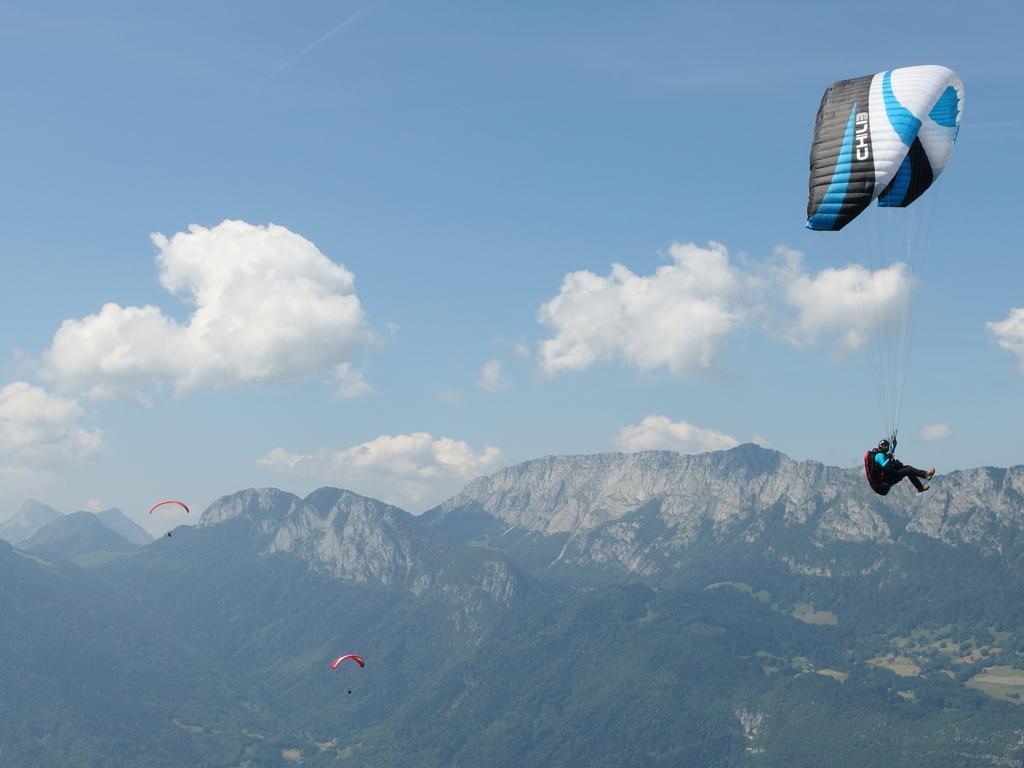How would you summarize this image in a sentence or two? In this image, we can see few paragliders. On the right side, we can see a person is in the air. Background we can see so many hills, trees and cloudy sky. 